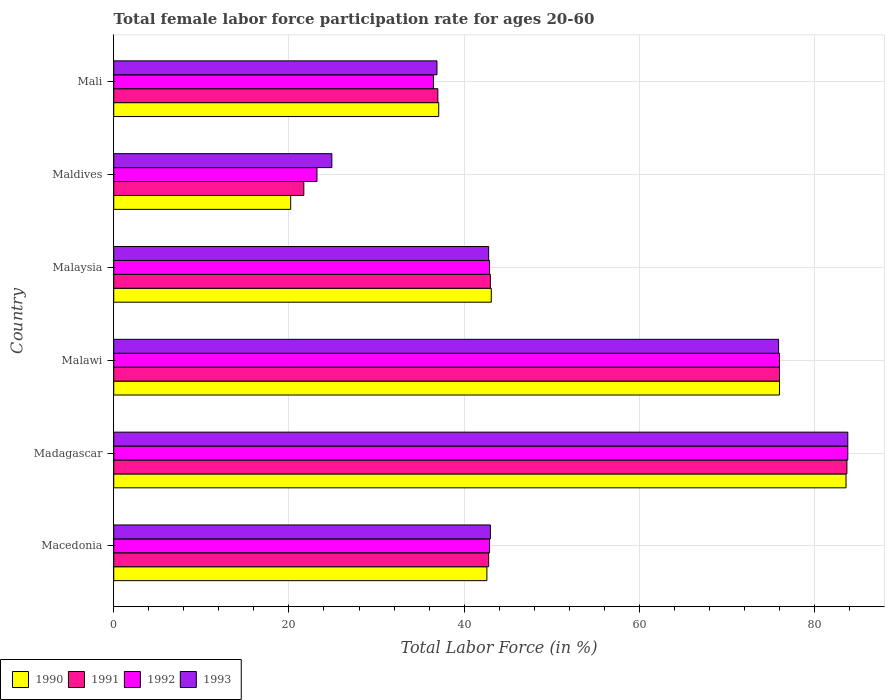How many different coloured bars are there?
Provide a short and direct response. 4. Are the number of bars per tick equal to the number of legend labels?
Ensure brevity in your answer.  Yes. How many bars are there on the 3rd tick from the top?
Give a very brief answer. 4. What is the label of the 5th group of bars from the top?
Offer a very short reply. Madagascar. In how many cases, is the number of bars for a given country not equal to the number of legend labels?
Your response must be concise. 0. What is the female labor force participation rate in 1992 in Macedonia?
Ensure brevity in your answer.  42.9. Across all countries, what is the maximum female labor force participation rate in 1991?
Your response must be concise. 83.7. Across all countries, what is the minimum female labor force participation rate in 1993?
Your response must be concise. 24.9. In which country was the female labor force participation rate in 1992 maximum?
Your answer should be very brief. Madagascar. In which country was the female labor force participation rate in 1991 minimum?
Your answer should be very brief. Maldives. What is the total female labor force participation rate in 1990 in the graph?
Offer a terse response. 302.6. What is the difference between the female labor force participation rate in 1990 in Malaysia and that in Maldives?
Make the answer very short. 22.9. What is the difference between the female labor force participation rate in 1990 in Malaysia and the female labor force participation rate in 1993 in Madagascar?
Your answer should be compact. -40.7. What is the average female labor force participation rate in 1990 per country?
Your answer should be very brief. 50.43. What is the difference between the female labor force participation rate in 1993 and female labor force participation rate in 1991 in Macedonia?
Your answer should be compact. 0.2. What is the ratio of the female labor force participation rate in 1992 in Malawi to that in Malaysia?
Your response must be concise. 1.77. Is the female labor force participation rate in 1990 in Maldives less than that in Mali?
Offer a very short reply. Yes. Is the difference between the female labor force participation rate in 1993 in Madagascar and Malawi greater than the difference between the female labor force participation rate in 1991 in Madagascar and Malawi?
Your response must be concise. Yes. What is the difference between the highest and the second highest female labor force participation rate in 1991?
Ensure brevity in your answer.  7.7. What is the difference between the highest and the lowest female labor force participation rate in 1991?
Keep it short and to the point. 62. Is it the case that in every country, the sum of the female labor force participation rate in 1991 and female labor force participation rate in 1993 is greater than the sum of female labor force participation rate in 1992 and female labor force participation rate in 1990?
Offer a terse response. No. What does the 4th bar from the top in Malaysia represents?
Make the answer very short. 1990. What does the 2nd bar from the bottom in Maldives represents?
Your answer should be very brief. 1991. Does the graph contain any zero values?
Provide a succinct answer. No. How are the legend labels stacked?
Provide a short and direct response. Horizontal. What is the title of the graph?
Offer a terse response. Total female labor force participation rate for ages 20-60. What is the label or title of the X-axis?
Keep it short and to the point. Total Labor Force (in %). What is the Total Labor Force (in %) in 1990 in Macedonia?
Keep it short and to the point. 42.6. What is the Total Labor Force (in %) in 1991 in Macedonia?
Provide a short and direct response. 42.8. What is the Total Labor Force (in %) in 1992 in Macedonia?
Your response must be concise. 42.9. What is the Total Labor Force (in %) in 1990 in Madagascar?
Provide a short and direct response. 83.6. What is the Total Labor Force (in %) of 1991 in Madagascar?
Your answer should be compact. 83.7. What is the Total Labor Force (in %) of 1992 in Madagascar?
Offer a very short reply. 83.8. What is the Total Labor Force (in %) in 1993 in Madagascar?
Make the answer very short. 83.8. What is the Total Labor Force (in %) in 1993 in Malawi?
Offer a terse response. 75.9. What is the Total Labor Force (in %) in 1990 in Malaysia?
Your response must be concise. 43.1. What is the Total Labor Force (in %) of 1992 in Malaysia?
Your answer should be compact. 42.9. What is the Total Labor Force (in %) of 1993 in Malaysia?
Your response must be concise. 42.8. What is the Total Labor Force (in %) in 1990 in Maldives?
Offer a very short reply. 20.2. What is the Total Labor Force (in %) of 1991 in Maldives?
Your response must be concise. 21.7. What is the Total Labor Force (in %) in 1992 in Maldives?
Make the answer very short. 23.2. What is the Total Labor Force (in %) in 1993 in Maldives?
Your answer should be very brief. 24.9. What is the Total Labor Force (in %) of 1990 in Mali?
Offer a terse response. 37.1. What is the Total Labor Force (in %) in 1991 in Mali?
Offer a terse response. 37. What is the Total Labor Force (in %) in 1992 in Mali?
Your answer should be compact. 36.5. What is the Total Labor Force (in %) in 1993 in Mali?
Ensure brevity in your answer.  36.9. Across all countries, what is the maximum Total Labor Force (in %) of 1990?
Provide a short and direct response. 83.6. Across all countries, what is the maximum Total Labor Force (in %) in 1991?
Provide a short and direct response. 83.7. Across all countries, what is the maximum Total Labor Force (in %) in 1992?
Make the answer very short. 83.8. Across all countries, what is the maximum Total Labor Force (in %) in 1993?
Give a very brief answer. 83.8. Across all countries, what is the minimum Total Labor Force (in %) of 1990?
Offer a terse response. 20.2. Across all countries, what is the minimum Total Labor Force (in %) of 1991?
Your answer should be very brief. 21.7. Across all countries, what is the minimum Total Labor Force (in %) of 1992?
Give a very brief answer. 23.2. Across all countries, what is the minimum Total Labor Force (in %) of 1993?
Provide a succinct answer. 24.9. What is the total Total Labor Force (in %) of 1990 in the graph?
Ensure brevity in your answer.  302.6. What is the total Total Labor Force (in %) of 1991 in the graph?
Ensure brevity in your answer.  304.2. What is the total Total Labor Force (in %) of 1992 in the graph?
Make the answer very short. 305.3. What is the total Total Labor Force (in %) in 1993 in the graph?
Your answer should be compact. 307.3. What is the difference between the Total Labor Force (in %) of 1990 in Macedonia and that in Madagascar?
Offer a very short reply. -41. What is the difference between the Total Labor Force (in %) of 1991 in Macedonia and that in Madagascar?
Your answer should be very brief. -40.9. What is the difference between the Total Labor Force (in %) in 1992 in Macedonia and that in Madagascar?
Offer a very short reply. -40.9. What is the difference between the Total Labor Force (in %) of 1993 in Macedonia and that in Madagascar?
Ensure brevity in your answer.  -40.8. What is the difference between the Total Labor Force (in %) in 1990 in Macedonia and that in Malawi?
Offer a terse response. -33.4. What is the difference between the Total Labor Force (in %) in 1991 in Macedonia and that in Malawi?
Provide a succinct answer. -33.2. What is the difference between the Total Labor Force (in %) of 1992 in Macedonia and that in Malawi?
Provide a short and direct response. -33.1. What is the difference between the Total Labor Force (in %) in 1993 in Macedonia and that in Malawi?
Offer a terse response. -32.9. What is the difference between the Total Labor Force (in %) in 1992 in Macedonia and that in Malaysia?
Make the answer very short. 0. What is the difference between the Total Labor Force (in %) in 1990 in Macedonia and that in Maldives?
Provide a succinct answer. 22.4. What is the difference between the Total Labor Force (in %) in 1991 in Macedonia and that in Maldives?
Give a very brief answer. 21.1. What is the difference between the Total Labor Force (in %) of 1992 in Macedonia and that in Maldives?
Keep it short and to the point. 19.7. What is the difference between the Total Labor Force (in %) in 1990 in Macedonia and that in Mali?
Make the answer very short. 5.5. What is the difference between the Total Labor Force (in %) of 1991 in Macedonia and that in Mali?
Make the answer very short. 5.8. What is the difference between the Total Labor Force (in %) of 1992 in Macedonia and that in Mali?
Give a very brief answer. 6.4. What is the difference between the Total Labor Force (in %) in 1992 in Madagascar and that in Malawi?
Provide a short and direct response. 7.8. What is the difference between the Total Labor Force (in %) in 1990 in Madagascar and that in Malaysia?
Your response must be concise. 40.5. What is the difference between the Total Labor Force (in %) in 1991 in Madagascar and that in Malaysia?
Offer a very short reply. 40.7. What is the difference between the Total Labor Force (in %) in 1992 in Madagascar and that in Malaysia?
Provide a short and direct response. 40.9. What is the difference between the Total Labor Force (in %) of 1993 in Madagascar and that in Malaysia?
Offer a very short reply. 41. What is the difference between the Total Labor Force (in %) of 1990 in Madagascar and that in Maldives?
Provide a succinct answer. 63.4. What is the difference between the Total Labor Force (in %) of 1991 in Madagascar and that in Maldives?
Keep it short and to the point. 62. What is the difference between the Total Labor Force (in %) in 1992 in Madagascar and that in Maldives?
Give a very brief answer. 60.6. What is the difference between the Total Labor Force (in %) of 1993 in Madagascar and that in Maldives?
Your answer should be very brief. 58.9. What is the difference between the Total Labor Force (in %) in 1990 in Madagascar and that in Mali?
Your response must be concise. 46.5. What is the difference between the Total Labor Force (in %) of 1991 in Madagascar and that in Mali?
Keep it short and to the point. 46.7. What is the difference between the Total Labor Force (in %) of 1992 in Madagascar and that in Mali?
Make the answer very short. 47.3. What is the difference between the Total Labor Force (in %) of 1993 in Madagascar and that in Mali?
Offer a very short reply. 46.9. What is the difference between the Total Labor Force (in %) in 1990 in Malawi and that in Malaysia?
Ensure brevity in your answer.  32.9. What is the difference between the Total Labor Force (in %) of 1991 in Malawi and that in Malaysia?
Ensure brevity in your answer.  33. What is the difference between the Total Labor Force (in %) in 1992 in Malawi and that in Malaysia?
Make the answer very short. 33.1. What is the difference between the Total Labor Force (in %) of 1993 in Malawi and that in Malaysia?
Provide a short and direct response. 33.1. What is the difference between the Total Labor Force (in %) of 1990 in Malawi and that in Maldives?
Your answer should be compact. 55.8. What is the difference between the Total Labor Force (in %) in 1991 in Malawi and that in Maldives?
Your answer should be compact. 54.3. What is the difference between the Total Labor Force (in %) of 1992 in Malawi and that in Maldives?
Offer a terse response. 52.8. What is the difference between the Total Labor Force (in %) of 1993 in Malawi and that in Maldives?
Give a very brief answer. 51. What is the difference between the Total Labor Force (in %) in 1990 in Malawi and that in Mali?
Give a very brief answer. 38.9. What is the difference between the Total Labor Force (in %) in 1991 in Malawi and that in Mali?
Your response must be concise. 39. What is the difference between the Total Labor Force (in %) in 1992 in Malawi and that in Mali?
Offer a very short reply. 39.5. What is the difference between the Total Labor Force (in %) of 1993 in Malawi and that in Mali?
Your answer should be compact. 39. What is the difference between the Total Labor Force (in %) of 1990 in Malaysia and that in Maldives?
Give a very brief answer. 22.9. What is the difference between the Total Labor Force (in %) in 1991 in Malaysia and that in Maldives?
Keep it short and to the point. 21.3. What is the difference between the Total Labor Force (in %) of 1993 in Malaysia and that in Maldives?
Your response must be concise. 17.9. What is the difference between the Total Labor Force (in %) of 1991 in Malaysia and that in Mali?
Offer a very short reply. 6. What is the difference between the Total Labor Force (in %) of 1992 in Malaysia and that in Mali?
Keep it short and to the point. 6.4. What is the difference between the Total Labor Force (in %) of 1993 in Malaysia and that in Mali?
Provide a succinct answer. 5.9. What is the difference between the Total Labor Force (in %) in 1990 in Maldives and that in Mali?
Offer a terse response. -16.9. What is the difference between the Total Labor Force (in %) of 1991 in Maldives and that in Mali?
Your answer should be very brief. -15.3. What is the difference between the Total Labor Force (in %) of 1992 in Maldives and that in Mali?
Offer a terse response. -13.3. What is the difference between the Total Labor Force (in %) in 1993 in Maldives and that in Mali?
Provide a short and direct response. -12. What is the difference between the Total Labor Force (in %) in 1990 in Macedonia and the Total Labor Force (in %) in 1991 in Madagascar?
Give a very brief answer. -41.1. What is the difference between the Total Labor Force (in %) of 1990 in Macedonia and the Total Labor Force (in %) of 1992 in Madagascar?
Provide a succinct answer. -41.2. What is the difference between the Total Labor Force (in %) in 1990 in Macedonia and the Total Labor Force (in %) in 1993 in Madagascar?
Provide a succinct answer. -41.2. What is the difference between the Total Labor Force (in %) in 1991 in Macedonia and the Total Labor Force (in %) in 1992 in Madagascar?
Make the answer very short. -41. What is the difference between the Total Labor Force (in %) in 1991 in Macedonia and the Total Labor Force (in %) in 1993 in Madagascar?
Offer a very short reply. -41. What is the difference between the Total Labor Force (in %) in 1992 in Macedonia and the Total Labor Force (in %) in 1993 in Madagascar?
Your answer should be very brief. -40.9. What is the difference between the Total Labor Force (in %) of 1990 in Macedonia and the Total Labor Force (in %) of 1991 in Malawi?
Your response must be concise. -33.4. What is the difference between the Total Labor Force (in %) in 1990 in Macedonia and the Total Labor Force (in %) in 1992 in Malawi?
Keep it short and to the point. -33.4. What is the difference between the Total Labor Force (in %) in 1990 in Macedonia and the Total Labor Force (in %) in 1993 in Malawi?
Give a very brief answer. -33.3. What is the difference between the Total Labor Force (in %) in 1991 in Macedonia and the Total Labor Force (in %) in 1992 in Malawi?
Your answer should be compact. -33.2. What is the difference between the Total Labor Force (in %) in 1991 in Macedonia and the Total Labor Force (in %) in 1993 in Malawi?
Provide a succinct answer. -33.1. What is the difference between the Total Labor Force (in %) of 1992 in Macedonia and the Total Labor Force (in %) of 1993 in Malawi?
Your response must be concise. -33. What is the difference between the Total Labor Force (in %) of 1990 in Macedonia and the Total Labor Force (in %) of 1993 in Malaysia?
Keep it short and to the point. -0.2. What is the difference between the Total Labor Force (in %) in 1991 in Macedonia and the Total Labor Force (in %) in 1992 in Malaysia?
Offer a very short reply. -0.1. What is the difference between the Total Labor Force (in %) in 1990 in Macedonia and the Total Labor Force (in %) in 1991 in Maldives?
Your response must be concise. 20.9. What is the difference between the Total Labor Force (in %) in 1990 in Macedonia and the Total Labor Force (in %) in 1993 in Maldives?
Provide a succinct answer. 17.7. What is the difference between the Total Labor Force (in %) of 1991 in Macedonia and the Total Labor Force (in %) of 1992 in Maldives?
Ensure brevity in your answer.  19.6. What is the difference between the Total Labor Force (in %) of 1992 in Macedonia and the Total Labor Force (in %) of 1993 in Maldives?
Your response must be concise. 18. What is the difference between the Total Labor Force (in %) of 1991 in Macedonia and the Total Labor Force (in %) of 1992 in Mali?
Make the answer very short. 6.3. What is the difference between the Total Labor Force (in %) in 1992 in Macedonia and the Total Labor Force (in %) in 1993 in Mali?
Your answer should be compact. 6. What is the difference between the Total Labor Force (in %) of 1990 in Madagascar and the Total Labor Force (in %) of 1991 in Malawi?
Ensure brevity in your answer.  7.6. What is the difference between the Total Labor Force (in %) in 1990 in Madagascar and the Total Labor Force (in %) in 1992 in Malawi?
Your answer should be compact. 7.6. What is the difference between the Total Labor Force (in %) of 1991 in Madagascar and the Total Labor Force (in %) of 1993 in Malawi?
Provide a succinct answer. 7.8. What is the difference between the Total Labor Force (in %) of 1992 in Madagascar and the Total Labor Force (in %) of 1993 in Malawi?
Provide a short and direct response. 7.9. What is the difference between the Total Labor Force (in %) of 1990 in Madagascar and the Total Labor Force (in %) of 1991 in Malaysia?
Provide a short and direct response. 40.6. What is the difference between the Total Labor Force (in %) of 1990 in Madagascar and the Total Labor Force (in %) of 1992 in Malaysia?
Your answer should be compact. 40.7. What is the difference between the Total Labor Force (in %) of 1990 in Madagascar and the Total Labor Force (in %) of 1993 in Malaysia?
Provide a succinct answer. 40.8. What is the difference between the Total Labor Force (in %) of 1991 in Madagascar and the Total Labor Force (in %) of 1992 in Malaysia?
Offer a terse response. 40.8. What is the difference between the Total Labor Force (in %) of 1991 in Madagascar and the Total Labor Force (in %) of 1993 in Malaysia?
Give a very brief answer. 40.9. What is the difference between the Total Labor Force (in %) of 1990 in Madagascar and the Total Labor Force (in %) of 1991 in Maldives?
Provide a short and direct response. 61.9. What is the difference between the Total Labor Force (in %) of 1990 in Madagascar and the Total Labor Force (in %) of 1992 in Maldives?
Your response must be concise. 60.4. What is the difference between the Total Labor Force (in %) in 1990 in Madagascar and the Total Labor Force (in %) in 1993 in Maldives?
Provide a short and direct response. 58.7. What is the difference between the Total Labor Force (in %) of 1991 in Madagascar and the Total Labor Force (in %) of 1992 in Maldives?
Give a very brief answer. 60.5. What is the difference between the Total Labor Force (in %) of 1991 in Madagascar and the Total Labor Force (in %) of 1993 in Maldives?
Your answer should be compact. 58.8. What is the difference between the Total Labor Force (in %) in 1992 in Madagascar and the Total Labor Force (in %) in 1993 in Maldives?
Make the answer very short. 58.9. What is the difference between the Total Labor Force (in %) in 1990 in Madagascar and the Total Labor Force (in %) in 1991 in Mali?
Provide a short and direct response. 46.6. What is the difference between the Total Labor Force (in %) in 1990 in Madagascar and the Total Labor Force (in %) in 1992 in Mali?
Offer a terse response. 47.1. What is the difference between the Total Labor Force (in %) of 1990 in Madagascar and the Total Labor Force (in %) of 1993 in Mali?
Provide a short and direct response. 46.7. What is the difference between the Total Labor Force (in %) in 1991 in Madagascar and the Total Labor Force (in %) in 1992 in Mali?
Provide a short and direct response. 47.2. What is the difference between the Total Labor Force (in %) of 1991 in Madagascar and the Total Labor Force (in %) of 1993 in Mali?
Offer a terse response. 46.8. What is the difference between the Total Labor Force (in %) in 1992 in Madagascar and the Total Labor Force (in %) in 1993 in Mali?
Provide a succinct answer. 46.9. What is the difference between the Total Labor Force (in %) of 1990 in Malawi and the Total Labor Force (in %) of 1991 in Malaysia?
Give a very brief answer. 33. What is the difference between the Total Labor Force (in %) in 1990 in Malawi and the Total Labor Force (in %) in 1992 in Malaysia?
Give a very brief answer. 33.1. What is the difference between the Total Labor Force (in %) in 1990 in Malawi and the Total Labor Force (in %) in 1993 in Malaysia?
Ensure brevity in your answer.  33.2. What is the difference between the Total Labor Force (in %) of 1991 in Malawi and the Total Labor Force (in %) of 1992 in Malaysia?
Offer a terse response. 33.1. What is the difference between the Total Labor Force (in %) in 1991 in Malawi and the Total Labor Force (in %) in 1993 in Malaysia?
Make the answer very short. 33.2. What is the difference between the Total Labor Force (in %) of 1992 in Malawi and the Total Labor Force (in %) of 1993 in Malaysia?
Your answer should be very brief. 33.2. What is the difference between the Total Labor Force (in %) of 1990 in Malawi and the Total Labor Force (in %) of 1991 in Maldives?
Give a very brief answer. 54.3. What is the difference between the Total Labor Force (in %) of 1990 in Malawi and the Total Labor Force (in %) of 1992 in Maldives?
Make the answer very short. 52.8. What is the difference between the Total Labor Force (in %) of 1990 in Malawi and the Total Labor Force (in %) of 1993 in Maldives?
Your answer should be compact. 51.1. What is the difference between the Total Labor Force (in %) in 1991 in Malawi and the Total Labor Force (in %) in 1992 in Maldives?
Your answer should be very brief. 52.8. What is the difference between the Total Labor Force (in %) of 1991 in Malawi and the Total Labor Force (in %) of 1993 in Maldives?
Your response must be concise. 51.1. What is the difference between the Total Labor Force (in %) of 1992 in Malawi and the Total Labor Force (in %) of 1993 in Maldives?
Provide a succinct answer. 51.1. What is the difference between the Total Labor Force (in %) of 1990 in Malawi and the Total Labor Force (in %) of 1992 in Mali?
Ensure brevity in your answer.  39.5. What is the difference between the Total Labor Force (in %) in 1990 in Malawi and the Total Labor Force (in %) in 1993 in Mali?
Offer a terse response. 39.1. What is the difference between the Total Labor Force (in %) in 1991 in Malawi and the Total Labor Force (in %) in 1992 in Mali?
Provide a succinct answer. 39.5. What is the difference between the Total Labor Force (in %) in 1991 in Malawi and the Total Labor Force (in %) in 1993 in Mali?
Your answer should be compact. 39.1. What is the difference between the Total Labor Force (in %) of 1992 in Malawi and the Total Labor Force (in %) of 1993 in Mali?
Provide a short and direct response. 39.1. What is the difference between the Total Labor Force (in %) of 1990 in Malaysia and the Total Labor Force (in %) of 1991 in Maldives?
Offer a terse response. 21.4. What is the difference between the Total Labor Force (in %) of 1990 in Malaysia and the Total Labor Force (in %) of 1992 in Maldives?
Ensure brevity in your answer.  19.9. What is the difference between the Total Labor Force (in %) of 1991 in Malaysia and the Total Labor Force (in %) of 1992 in Maldives?
Provide a short and direct response. 19.8. What is the difference between the Total Labor Force (in %) of 1991 in Malaysia and the Total Labor Force (in %) of 1993 in Maldives?
Your answer should be very brief. 18.1. What is the difference between the Total Labor Force (in %) in 1990 in Malaysia and the Total Labor Force (in %) in 1991 in Mali?
Ensure brevity in your answer.  6.1. What is the difference between the Total Labor Force (in %) in 1990 in Malaysia and the Total Labor Force (in %) in 1992 in Mali?
Ensure brevity in your answer.  6.6. What is the difference between the Total Labor Force (in %) in 1991 in Malaysia and the Total Labor Force (in %) in 1992 in Mali?
Provide a succinct answer. 6.5. What is the difference between the Total Labor Force (in %) in 1990 in Maldives and the Total Labor Force (in %) in 1991 in Mali?
Your answer should be very brief. -16.8. What is the difference between the Total Labor Force (in %) of 1990 in Maldives and the Total Labor Force (in %) of 1992 in Mali?
Provide a short and direct response. -16.3. What is the difference between the Total Labor Force (in %) in 1990 in Maldives and the Total Labor Force (in %) in 1993 in Mali?
Your answer should be very brief. -16.7. What is the difference between the Total Labor Force (in %) of 1991 in Maldives and the Total Labor Force (in %) of 1992 in Mali?
Make the answer very short. -14.8. What is the difference between the Total Labor Force (in %) in 1991 in Maldives and the Total Labor Force (in %) in 1993 in Mali?
Your answer should be compact. -15.2. What is the difference between the Total Labor Force (in %) in 1992 in Maldives and the Total Labor Force (in %) in 1993 in Mali?
Your answer should be compact. -13.7. What is the average Total Labor Force (in %) in 1990 per country?
Offer a terse response. 50.43. What is the average Total Labor Force (in %) in 1991 per country?
Your answer should be very brief. 50.7. What is the average Total Labor Force (in %) in 1992 per country?
Give a very brief answer. 50.88. What is the average Total Labor Force (in %) of 1993 per country?
Ensure brevity in your answer.  51.22. What is the difference between the Total Labor Force (in %) in 1990 and Total Labor Force (in %) in 1993 in Macedonia?
Give a very brief answer. -0.4. What is the difference between the Total Labor Force (in %) of 1991 and Total Labor Force (in %) of 1993 in Macedonia?
Provide a short and direct response. -0.2. What is the difference between the Total Labor Force (in %) in 1992 and Total Labor Force (in %) in 1993 in Macedonia?
Provide a succinct answer. -0.1. What is the difference between the Total Labor Force (in %) in 1990 and Total Labor Force (in %) in 1992 in Madagascar?
Your answer should be compact. -0.2. What is the difference between the Total Labor Force (in %) of 1990 and Total Labor Force (in %) of 1993 in Madagascar?
Make the answer very short. -0.2. What is the difference between the Total Labor Force (in %) of 1991 and Total Labor Force (in %) of 1992 in Madagascar?
Your answer should be very brief. -0.1. What is the difference between the Total Labor Force (in %) of 1991 and Total Labor Force (in %) of 1992 in Malawi?
Give a very brief answer. 0. What is the difference between the Total Labor Force (in %) in 1991 and Total Labor Force (in %) in 1993 in Malawi?
Offer a very short reply. 0.1. What is the difference between the Total Labor Force (in %) in 1990 and Total Labor Force (in %) in 1991 in Malaysia?
Give a very brief answer. 0.1. What is the difference between the Total Labor Force (in %) of 1990 and Total Labor Force (in %) of 1992 in Malaysia?
Provide a succinct answer. 0.2. What is the difference between the Total Labor Force (in %) of 1990 and Total Labor Force (in %) of 1993 in Malaysia?
Ensure brevity in your answer.  0.3. What is the difference between the Total Labor Force (in %) of 1991 and Total Labor Force (in %) of 1992 in Malaysia?
Your response must be concise. 0.1. What is the difference between the Total Labor Force (in %) in 1990 and Total Labor Force (in %) in 1991 in Maldives?
Offer a terse response. -1.5. What is the difference between the Total Labor Force (in %) of 1991 and Total Labor Force (in %) of 1992 in Maldives?
Your response must be concise. -1.5. What is the difference between the Total Labor Force (in %) of 1991 and Total Labor Force (in %) of 1993 in Maldives?
Your answer should be compact. -3.2. What is the difference between the Total Labor Force (in %) of 1990 and Total Labor Force (in %) of 1991 in Mali?
Keep it short and to the point. 0.1. What is the difference between the Total Labor Force (in %) in 1990 and Total Labor Force (in %) in 1992 in Mali?
Provide a succinct answer. 0.6. What is the difference between the Total Labor Force (in %) of 1991 and Total Labor Force (in %) of 1992 in Mali?
Offer a very short reply. 0.5. What is the difference between the Total Labor Force (in %) in 1992 and Total Labor Force (in %) in 1993 in Mali?
Your answer should be compact. -0.4. What is the ratio of the Total Labor Force (in %) in 1990 in Macedonia to that in Madagascar?
Keep it short and to the point. 0.51. What is the ratio of the Total Labor Force (in %) of 1991 in Macedonia to that in Madagascar?
Your answer should be very brief. 0.51. What is the ratio of the Total Labor Force (in %) in 1992 in Macedonia to that in Madagascar?
Provide a short and direct response. 0.51. What is the ratio of the Total Labor Force (in %) in 1993 in Macedonia to that in Madagascar?
Make the answer very short. 0.51. What is the ratio of the Total Labor Force (in %) in 1990 in Macedonia to that in Malawi?
Provide a succinct answer. 0.56. What is the ratio of the Total Labor Force (in %) in 1991 in Macedonia to that in Malawi?
Make the answer very short. 0.56. What is the ratio of the Total Labor Force (in %) in 1992 in Macedonia to that in Malawi?
Your response must be concise. 0.56. What is the ratio of the Total Labor Force (in %) in 1993 in Macedonia to that in Malawi?
Your response must be concise. 0.57. What is the ratio of the Total Labor Force (in %) in 1990 in Macedonia to that in Malaysia?
Provide a short and direct response. 0.99. What is the ratio of the Total Labor Force (in %) of 1993 in Macedonia to that in Malaysia?
Your response must be concise. 1. What is the ratio of the Total Labor Force (in %) of 1990 in Macedonia to that in Maldives?
Make the answer very short. 2.11. What is the ratio of the Total Labor Force (in %) of 1991 in Macedonia to that in Maldives?
Give a very brief answer. 1.97. What is the ratio of the Total Labor Force (in %) of 1992 in Macedonia to that in Maldives?
Give a very brief answer. 1.85. What is the ratio of the Total Labor Force (in %) in 1993 in Macedonia to that in Maldives?
Give a very brief answer. 1.73. What is the ratio of the Total Labor Force (in %) in 1990 in Macedonia to that in Mali?
Keep it short and to the point. 1.15. What is the ratio of the Total Labor Force (in %) of 1991 in Macedonia to that in Mali?
Your answer should be very brief. 1.16. What is the ratio of the Total Labor Force (in %) of 1992 in Macedonia to that in Mali?
Your answer should be compact. 1.18. What is the ratio of the Total Labor Force (in %) of 1993 in Macedonia to that in Mali?
Provide a succinct answer. 1.17. What is the ratio of the Total Labor Force (in %) in 1991 in Madagascar to that in Malawi?
Your answer should be compact. 1.1. What is the ratio of the Total Labor Force (in %) in 1992 in Madagascar to that in Malawi?
Offer a very short reply. 1.1. What is the ratio of the Total Labor Force (in %) of 1993 in Madagascar to that in Malawi?
Offer a terse response. 1.1. What is the ratio of the Total Labor Force (in %) of 1990 in Madagascar to that in Malaysia?
Your response must be concise. 1.94. What is the ratio of the Total Labor Force (in %) of 1991 in Madagascar to that in Malaysia?
Ensure brevity in your answer.  1.95. What is the ratio of the Total Labor Force (in %) in 1992 in Madagascar to that in Malaysia?
Give a very brief answer. 1.95. What is the ratio of the Total Labor Force (in %) in 1993 in Madagascar to that in Malaysia?
Keep it short and to the point. 1.96. What is the ratio of the Total Labor Force (in %) in 1990 in Madagascar to that in Maldives?
Your answer should be very brief. 4.14. What is the ratio of the Total Labor Force (in %) in 1991 in Madagascar to that in Maldives?
Make the answer very short. 3.86. What is the ratio of the Total Labor Force (in %) of 1992 in Madagascar to that in Maldives?
Offer a terse response. 3.61. What is the ratio of the Total Labor Force (in %) of 1993 in Madagascar to that in Maldives?
Offer a terse response. 3.37. What is the ratio of the Total Labor Force (in %) of 1990 in Madagascar to that in Mali?
Provide a succinct answer. 2.25. What is the ratio of the Total Labor Force (in %) of 1991 in Madagascar to that in Mali?
Your answer should be very brief. 2.26. What is the ratio of the Total Labor Force (in %) in 1992 in Madagascar to that in Mali?
Give a very brief answer. 2.3. What is the ratio of the Total Labor Force (in %) of 1993 in Madagascar to that in Mali?
Offer a very short reply. 2.27. What is the ratio of the Total Labor Force (in %) in 1990 in Malawi to that in Malaysia?
Offer a terse response. 1.76. What is the ratio of the Total Labor Force (in %) in 1991 in Malawi to that in Malaysia?
Your answer should be very brief. 1.77. What is the ratio of the Total Labor Force (in %) of 1992 in Malawi to that in Malaysia?
Offer a very short reply. 1.77. What is the ratio of the Total Labor Force (in %) of 1993 in Malawi to that in Malaysia?
Give a very brief answer. 1.77. What is the ratio of the Total Labor Force (in %) of 1990 in Malawi to that in Maldives?
Your answer should be compact. 3.76. What is the ratio of the Total Labor Force (in %) in 1991 in Malawi to that in Maldives?
Your answer should be compact. 3.5. What is the ratio of the Total Labor Force (in %) of 1992 in Malawi to that in Maldives?
Provide a succinct answer. 3.28. What is the ratio of the Total Labor Force (in %) in 1993 in Malawi to that in Maldives?
Make the answer very short. 3.05. What is the ratio of the Total Labor Force (in %) of 1990 in Malawi to that in Mali?
Offer a terse response. 2.05. What is the ratio of the Total Labor Force (in %) in 1991 in Malawi to that in Mali?
Provide a succinct answer. 2.05. What is the ratio of the Total Labor Force (in %) of 1992 in Malawi to that in Mali?
Give a very brief answer. 2.08. What is the ratio of the Total Labor Force (in %) in 1993 in Malawi to that in Mali?
Offer a terse response. 2.06. What is the ratio of the Total Labor Force (in %) of 1990 in Malaysia to that in Maldives?
Ensure brevity in your answer.  2.13. What is the ratio of the Total Labor Force (in %) in 1991 in Malaysia to that in Maldives?
Ensure brevity in your answer.  1.98. What is the ratio of the Total Labor Force (in %) of 1992 in Malaysia to that in Maldives?
Offer a terse response. 1.85. What is the ratio of the Total Labor Force (in %) in 1993 in Malaysia to that in Maldives?
Provide a succinct answer. 1.72. What is the ratio of the Total Labor Force (in %) in 1990 in Malaysia to that in Mali?
Your answer should be very brief. 1.16. What is the ratio of the Total Labor Force (in %) of 1991 in Malaysia to that in Mali?
Your answer should be compact. 1.16. What is the ratio of the Total Labor Force (in %) in 1992 in Malaysia to that in Mali?
Offer a very short reply. 1.18. What is the ratio of the Total Labor Force (in %) of 1993 in Malaysia to that in Mali?
Your answer should be compact. 1.16. What is the ratio of the Total Labor Force (in %) of 1990 in Maldives to that in Mali?
Provide a short and direct response. 0.54. What is the ratio of the Total Labor Force (in %) of 1991 in Maldives to that in Mali?
Your answer should be compact. 0.59. What is the ratio of the Total Labor Force (in %) in 1992 in Maldives to that in Mali?
Your answer should be compact. 0.64. What is the ratio of the Total Labor Force (in %) of 1993 in Maldives to that in Mali?
Your response must be concise. 0.67. What is the difference between the highest and the second highest Total Labor Force (in %) in 1992?
Offer a terse response. 7.8. What is the difference between the highest and the lowest Total Labor Force (in %) in 1990?
Your answer should be very brief. 63.4. What is the difference between the highest and the lowest Total Labor Force (in %) in 1991?
Give a very brief answer. 62. What is the difference between the highest and the lowest Total Labor Force (in %) of 1992?
Make the answer very short. 60.6. What is the difference between the highest and the lowest Total Labor Force (in %) of 1993?
Give a very brief answer. 58.9. 